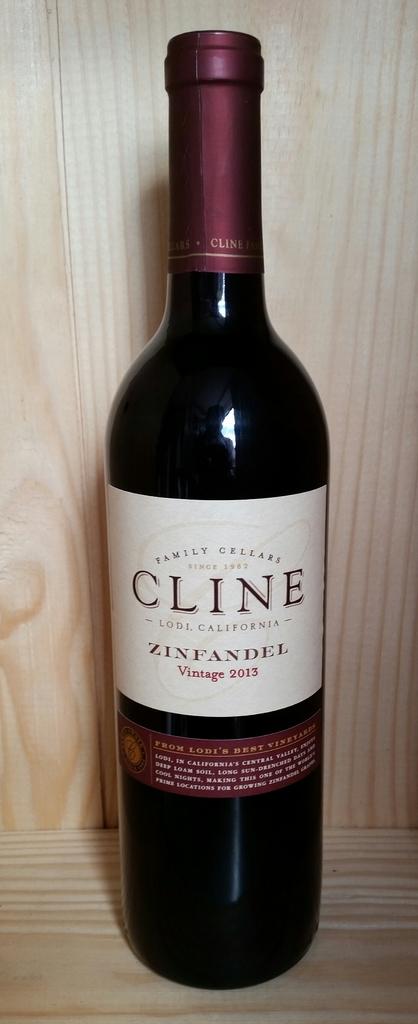What year is the wine?
Your answer should be compact. 2013. 